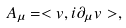<formula> <loc_0><loc_0><loc_500><loc_500>A _ { \mu } = < v , i \partial _ { \mu } v > ,</formula> 